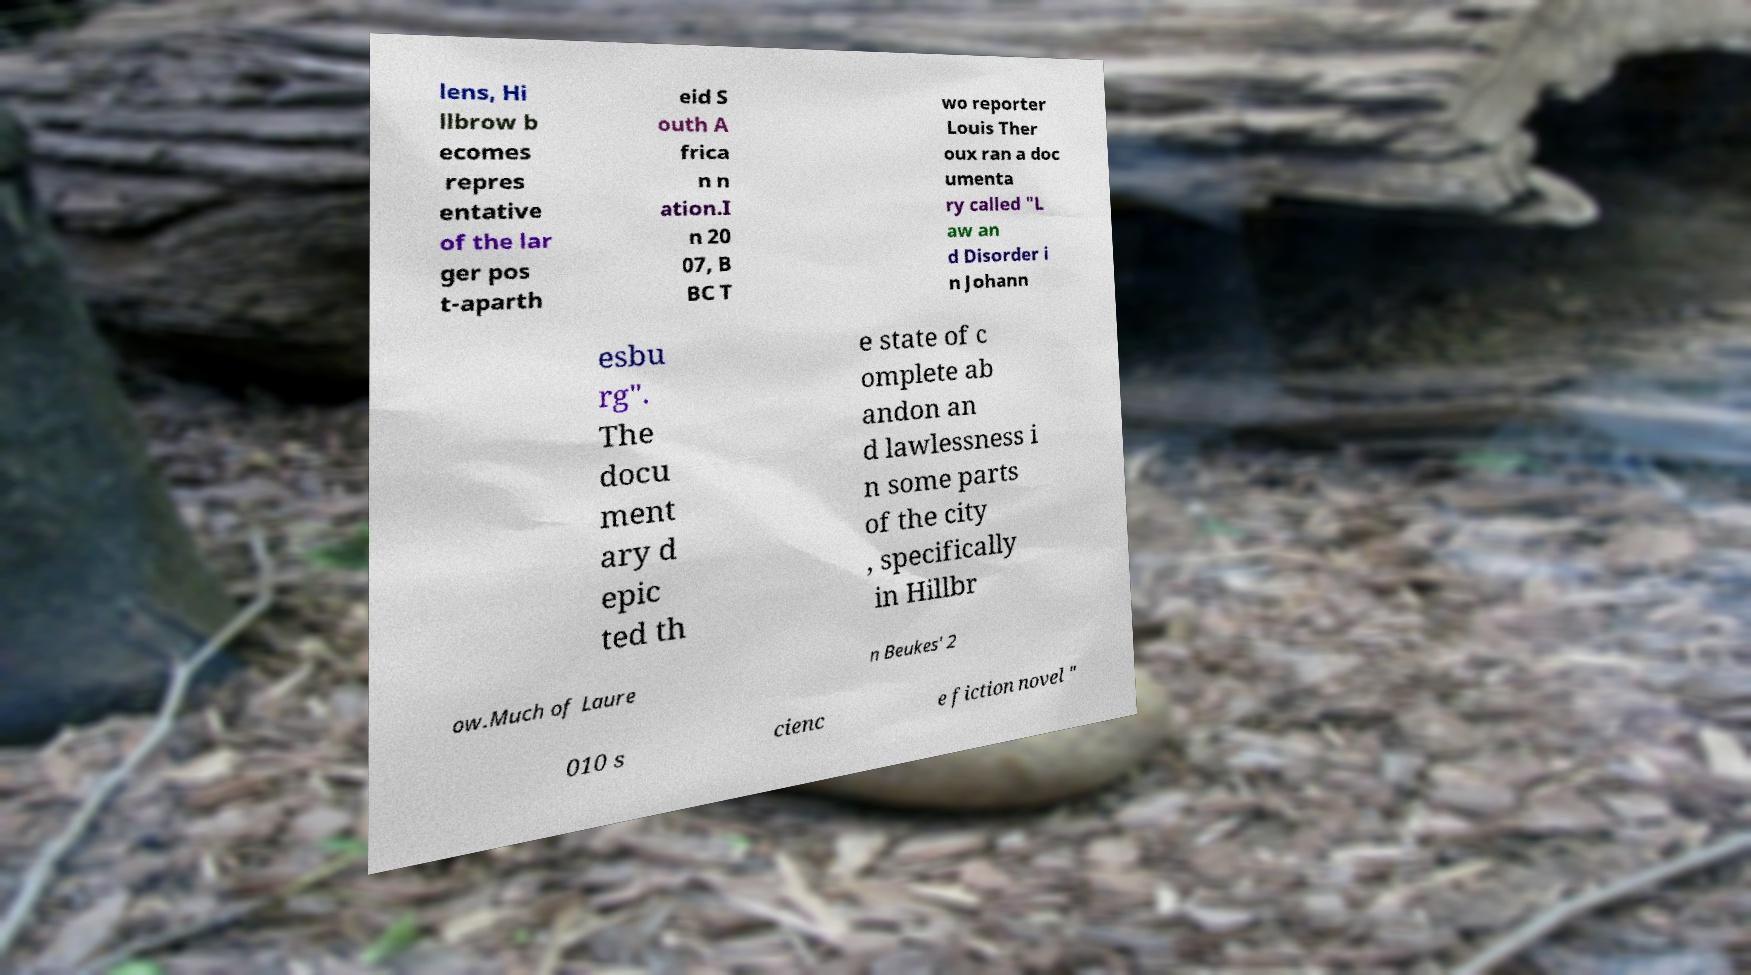Could you assist in decoding the text presented in this image and type it out clearly? lens, Hi llbrow b ecomes repres entative of the lar ger pos t-aparth eid S outh A frica n n ation.I n 20 07, B BC T wo reporter Louis Ther oux ran a doc umenta ry called "L aw an d Disorder i n Johann esbu rg". The docu ment ary d epic ted th e state of c omplete ab andon an d lawlessness i n some parts of the city , specifically in Hillbr ow.Much of Laure n Beukes' 2 010 s cienc e fiction novel " 